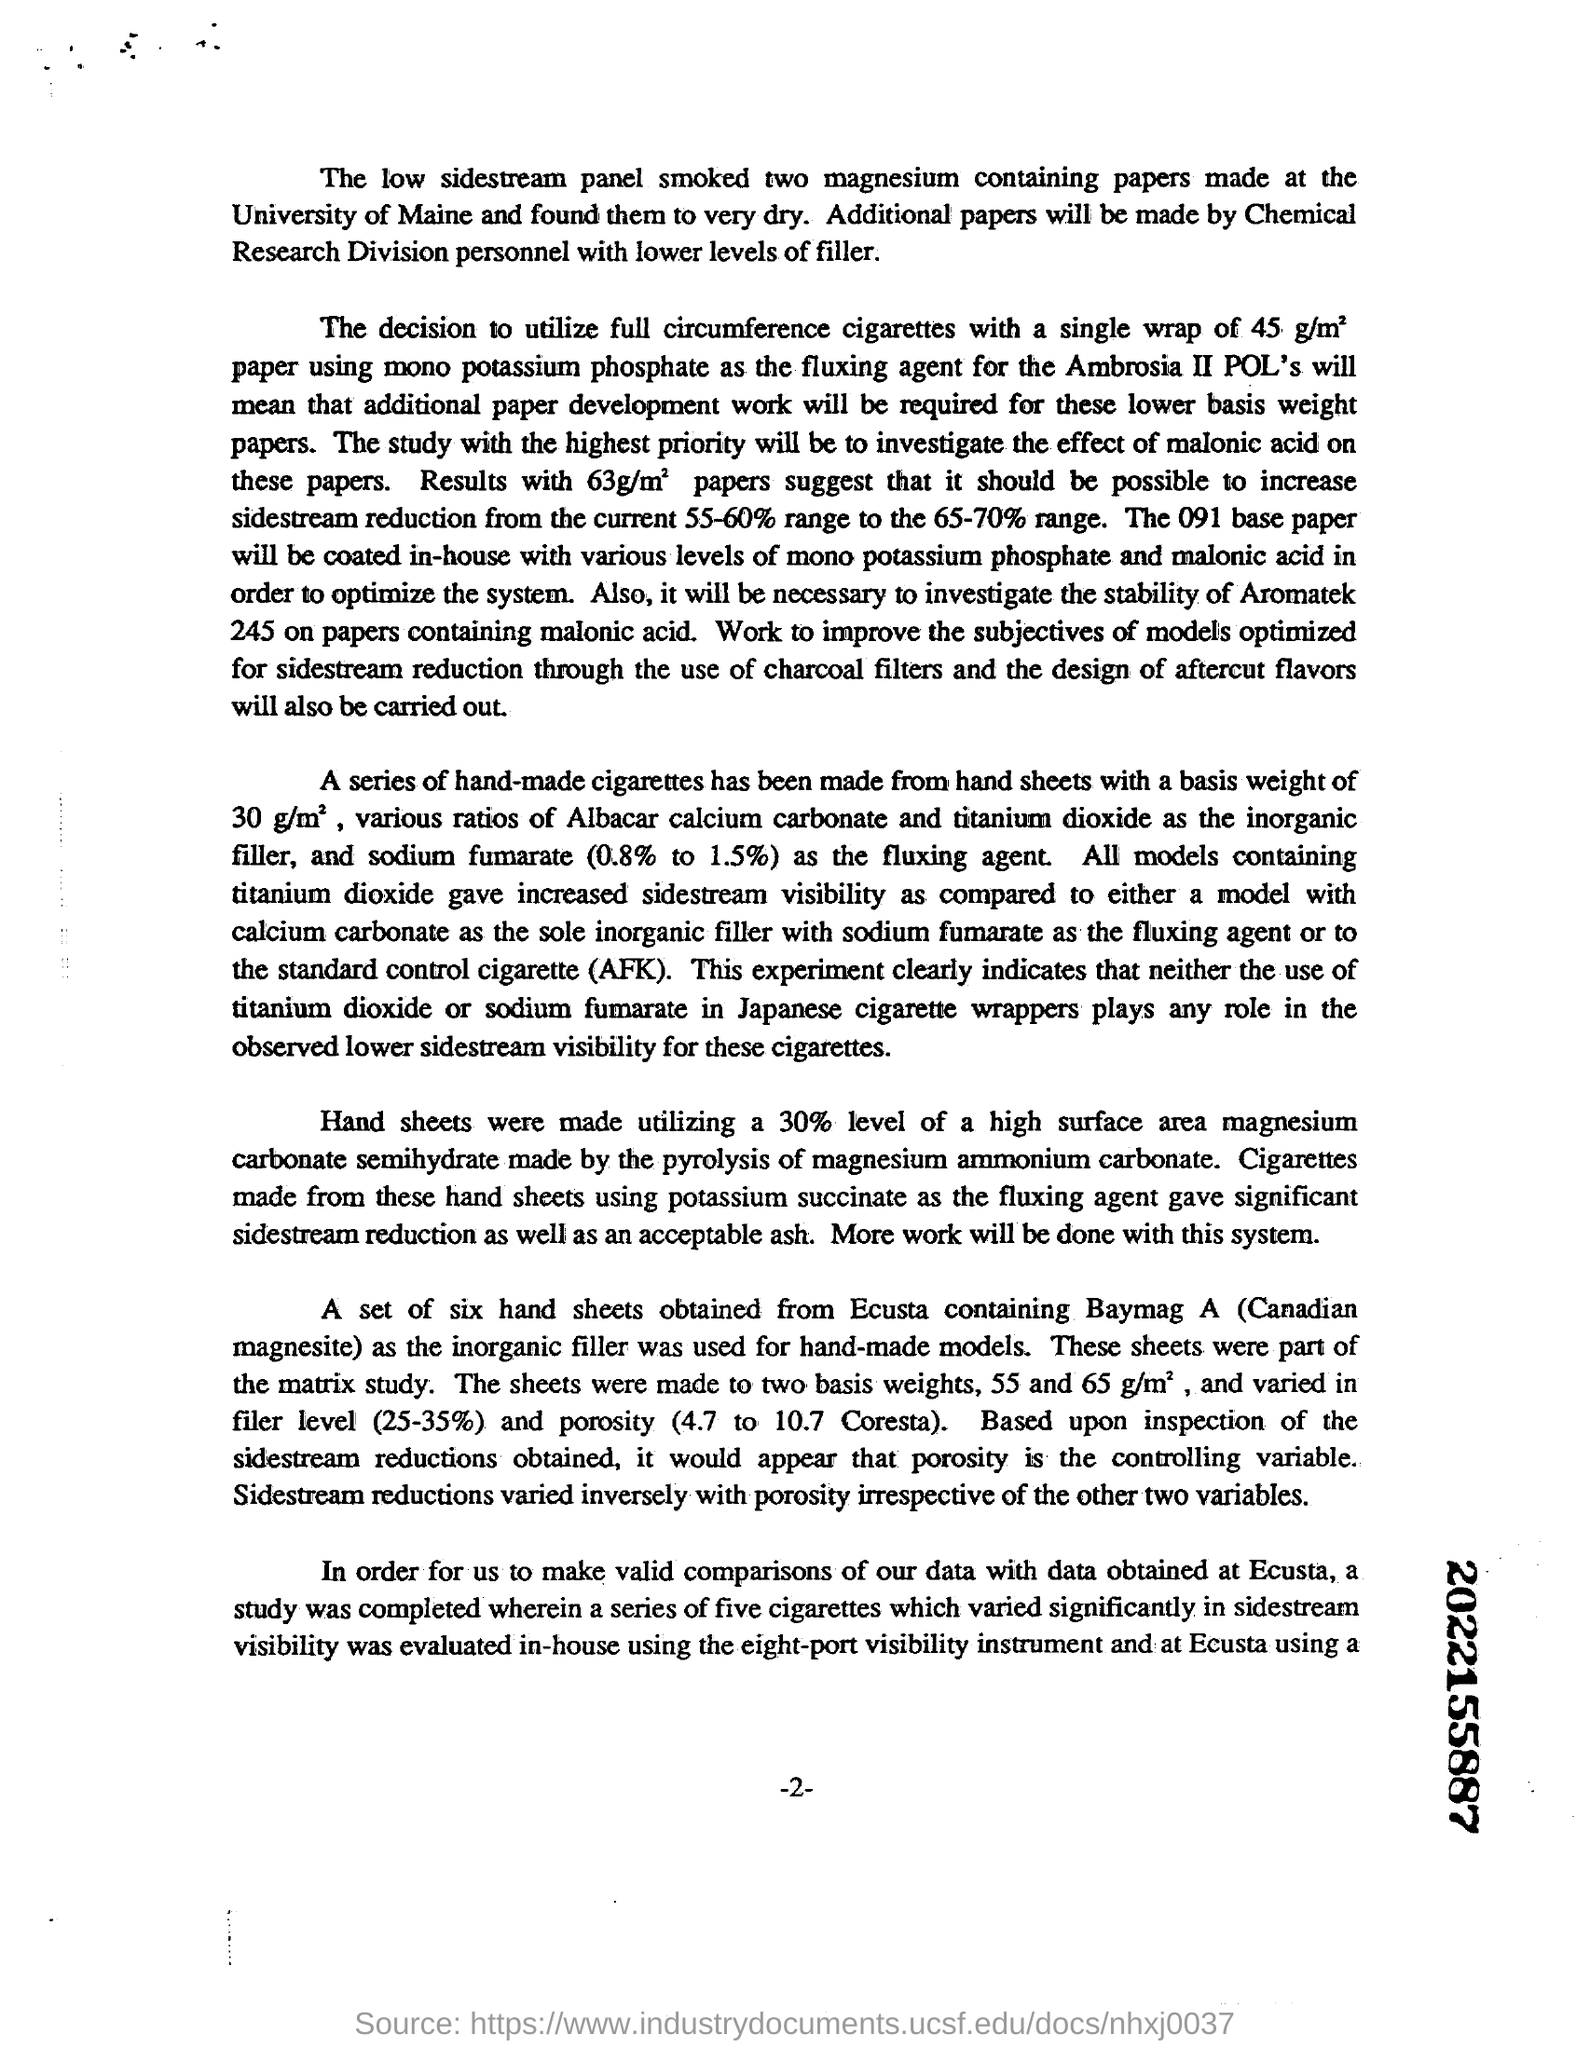Point out several critical features in this image. The two magnesium-containing papers were made at the University of Maine. We will use a specific base paper that will be coated in-house with varying levels of mono potassium phosphate and malonic acid to optimize the system. The code for this is 091.. We created hand sheets using 30% high surface area magnesium carbonate semihydrate, which was produced through the pyrolysis of magnesium ammonium carbonate. 